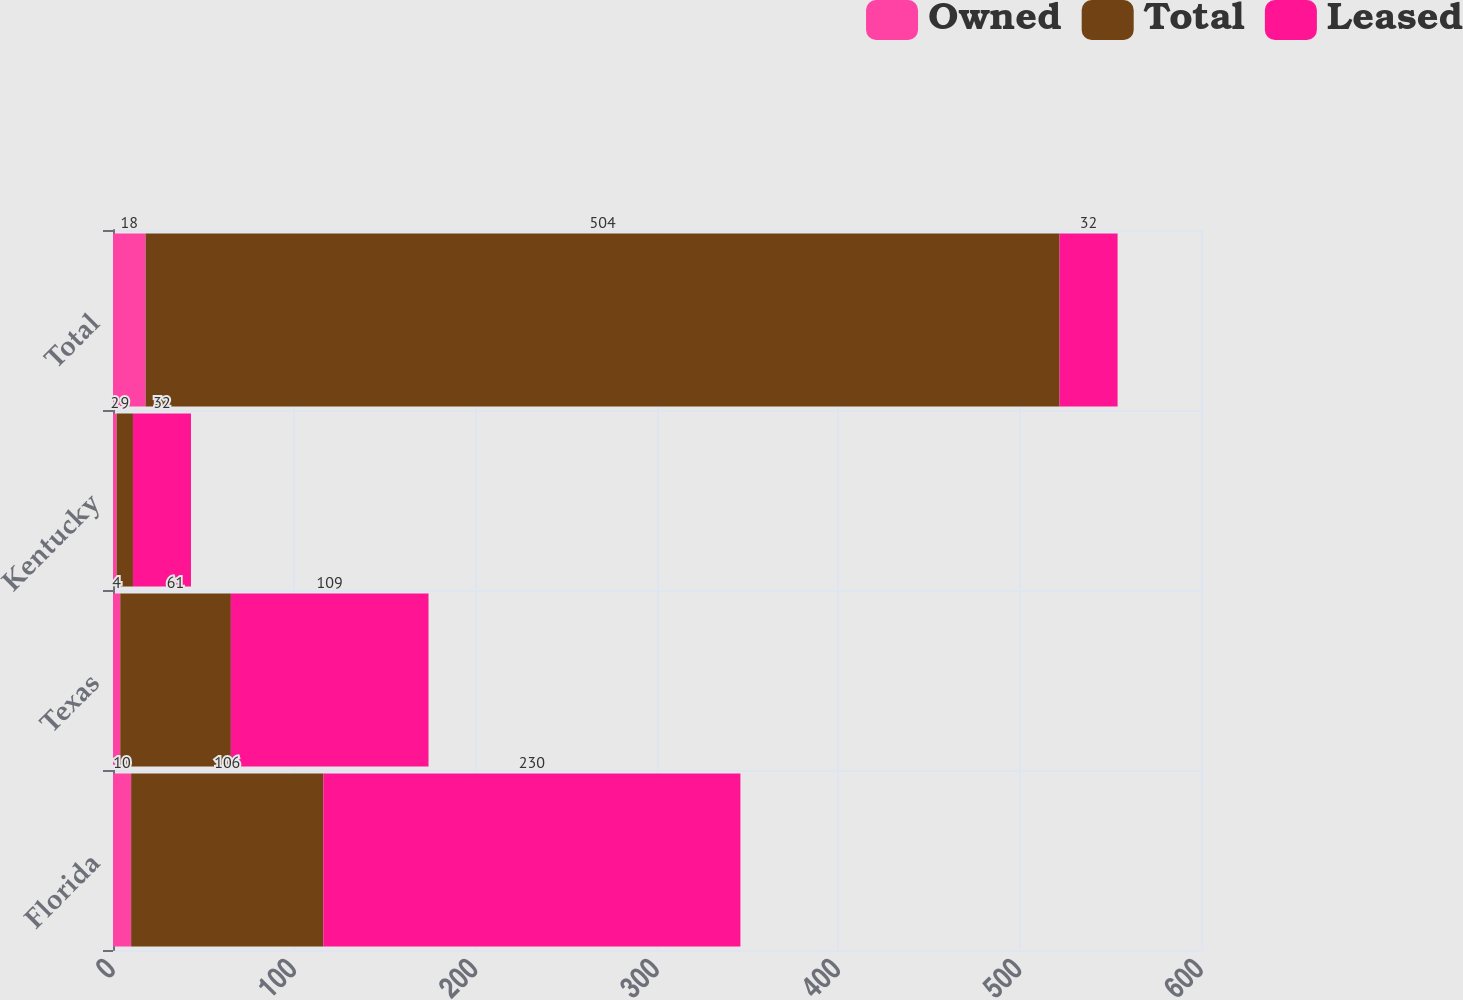<chart> <loc_0><loc_0><loc_500><loc_500><stacked_bar_chart><ecel><fcel>Florida<fcel>Texas<fcel>Kentucky<fcel>Total<nl><fcel>Owned<fcel>10<fcel>4<fcel>2<fcel>18<nl><fcel>Total<fcel>106<fcel>61<fcel>9<fcel>504<nl><fcel>Leased<fcel>230<fcel>109<fcel>32<fcel>32<nl></chart> 